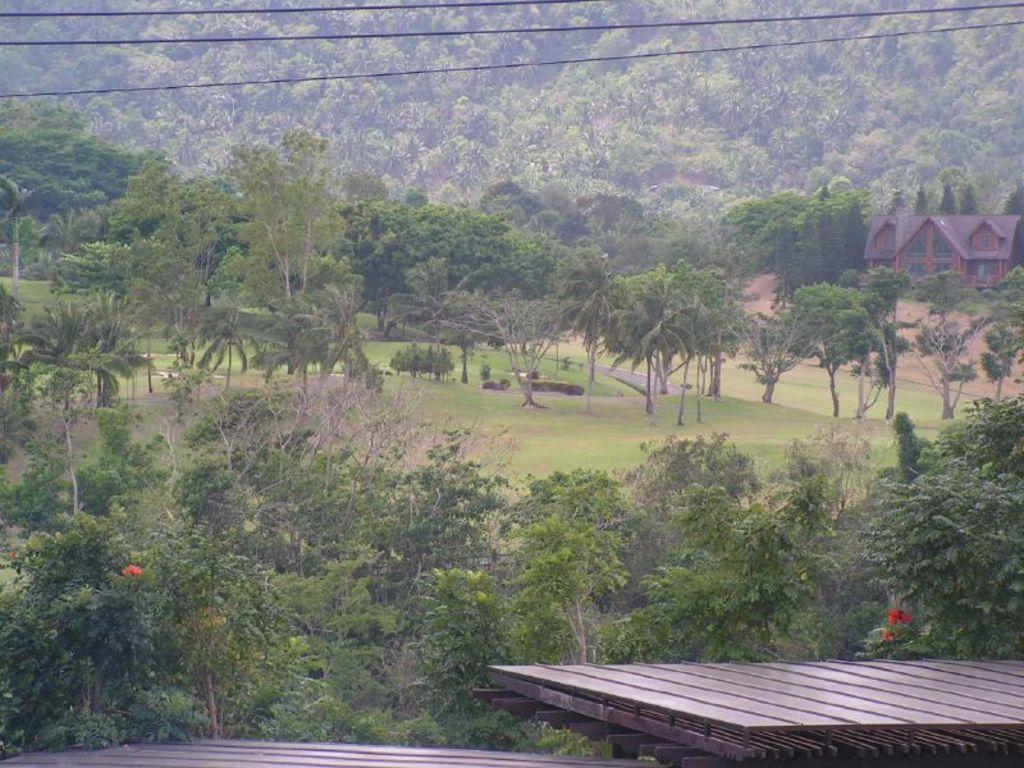Can you describe this image briefly? In this image there are wooden platforms, trees, house, grass, cables. 